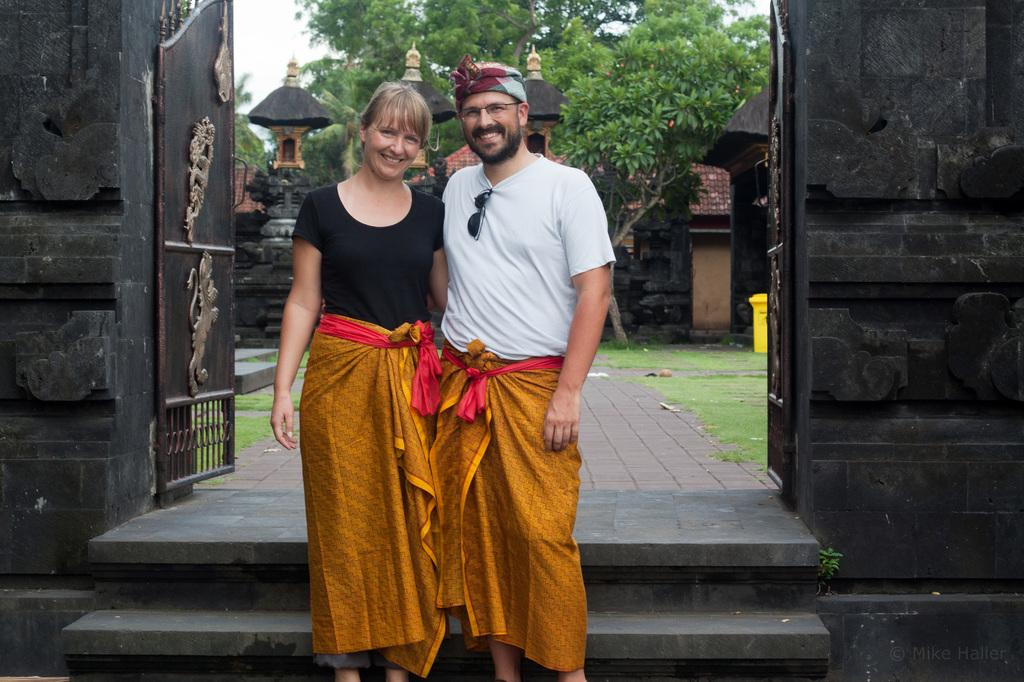How many people are in the image? There are two people in the image. What can be observed about their clothing? The people are wearing different color dresses. What can be seen in the background of the image? There is a metal gate, a wall, poles, many trees, and the sky visible in the background of the image. What time of day is it in the image, and what hand gesture is the person making? The time of day cannot be determined from the image, and there is no hand gesture visible. 